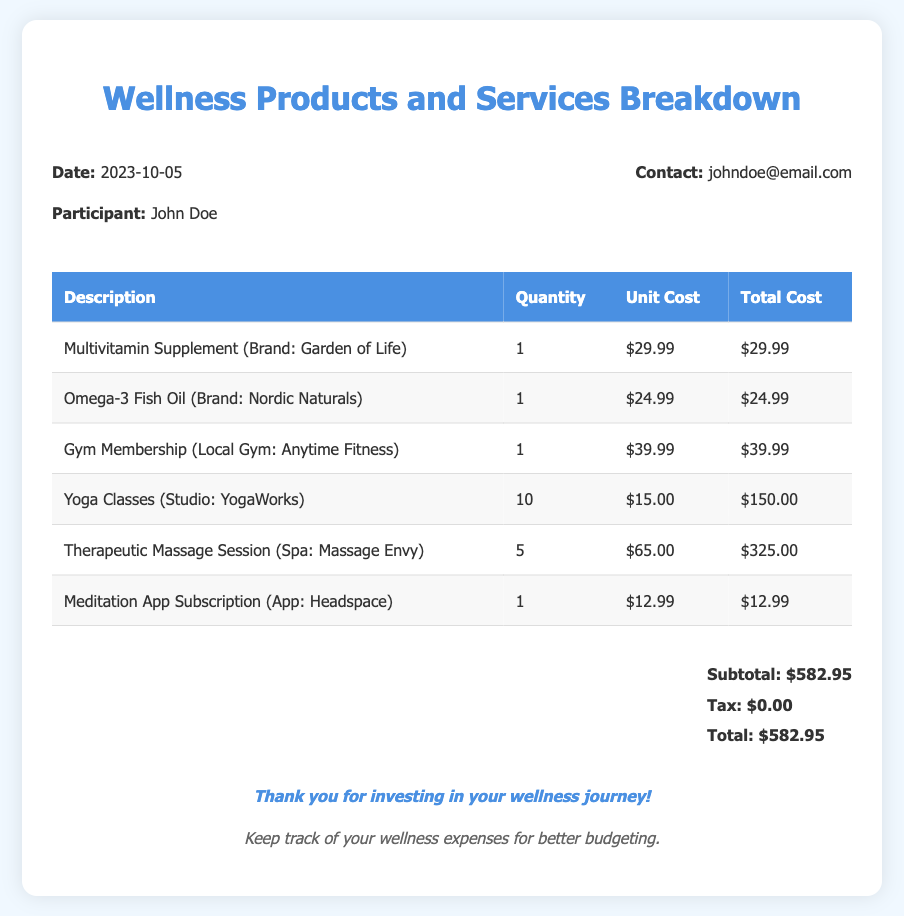What is the date of the bill? The date is specified in the document under "Date:", which is 2023-10-05.
Answer: 2023-10-05 Who is the participant listed on the bill? The participant's name is mentioned as "Participant:" in the document, which is John Doe.
Answer: John Doe What is the total cost of the wellness products and services? The total cost is summarized at the bottom of the document as "Total:", which is $582.95.
Answer: $582.95 How many yoga classes are included in the bill? The quantity of yoga classes is given under the "Quantity" column for Yoga Classes, which is 10.
Answer: 10 What is the unit cost of the therapeutic massage session? The unit cost for therapeutic massage session is listed under "Unit Cost" for that item, which is $65.00.
Answer: $65.00 Which meditation app is mentioned in the document? The meditation app is identified under the product description, which is Headspace.
Answer: Headspace What is the subtotal before tax? The subtotal amount can be found under "Subtotal:" in the summary section, which is $582.95.
Answer: $582.95 How many therapeutic massage sessions were included? The quantity for therapeutic massage sessions is indicated in the document as 5.
Answer: 5 